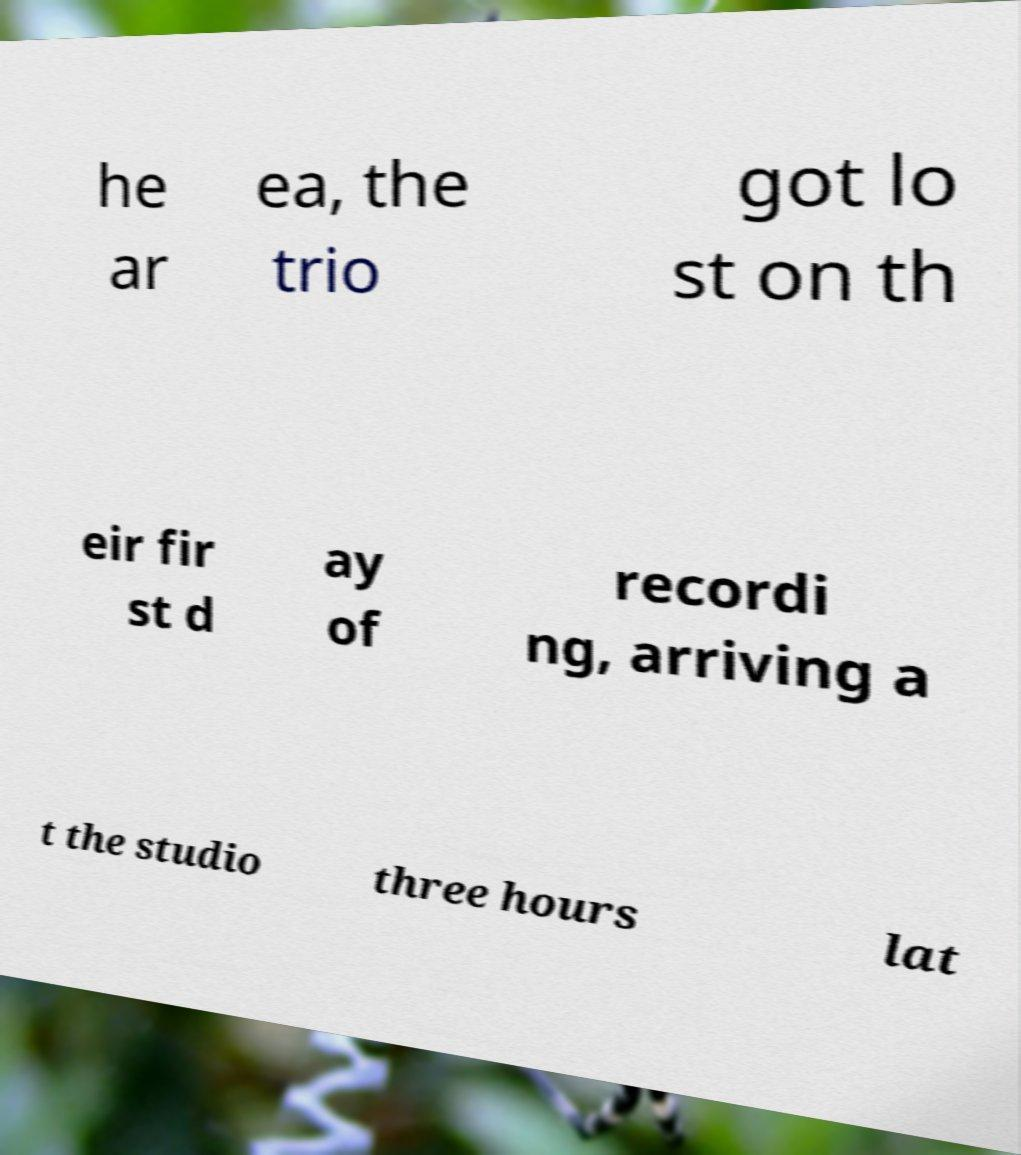Could you extract and type out the text from this image? he ar ea, the trio got lo st on th eir fir st d ay of recordi ng, arriving a t the studio three hours lat 